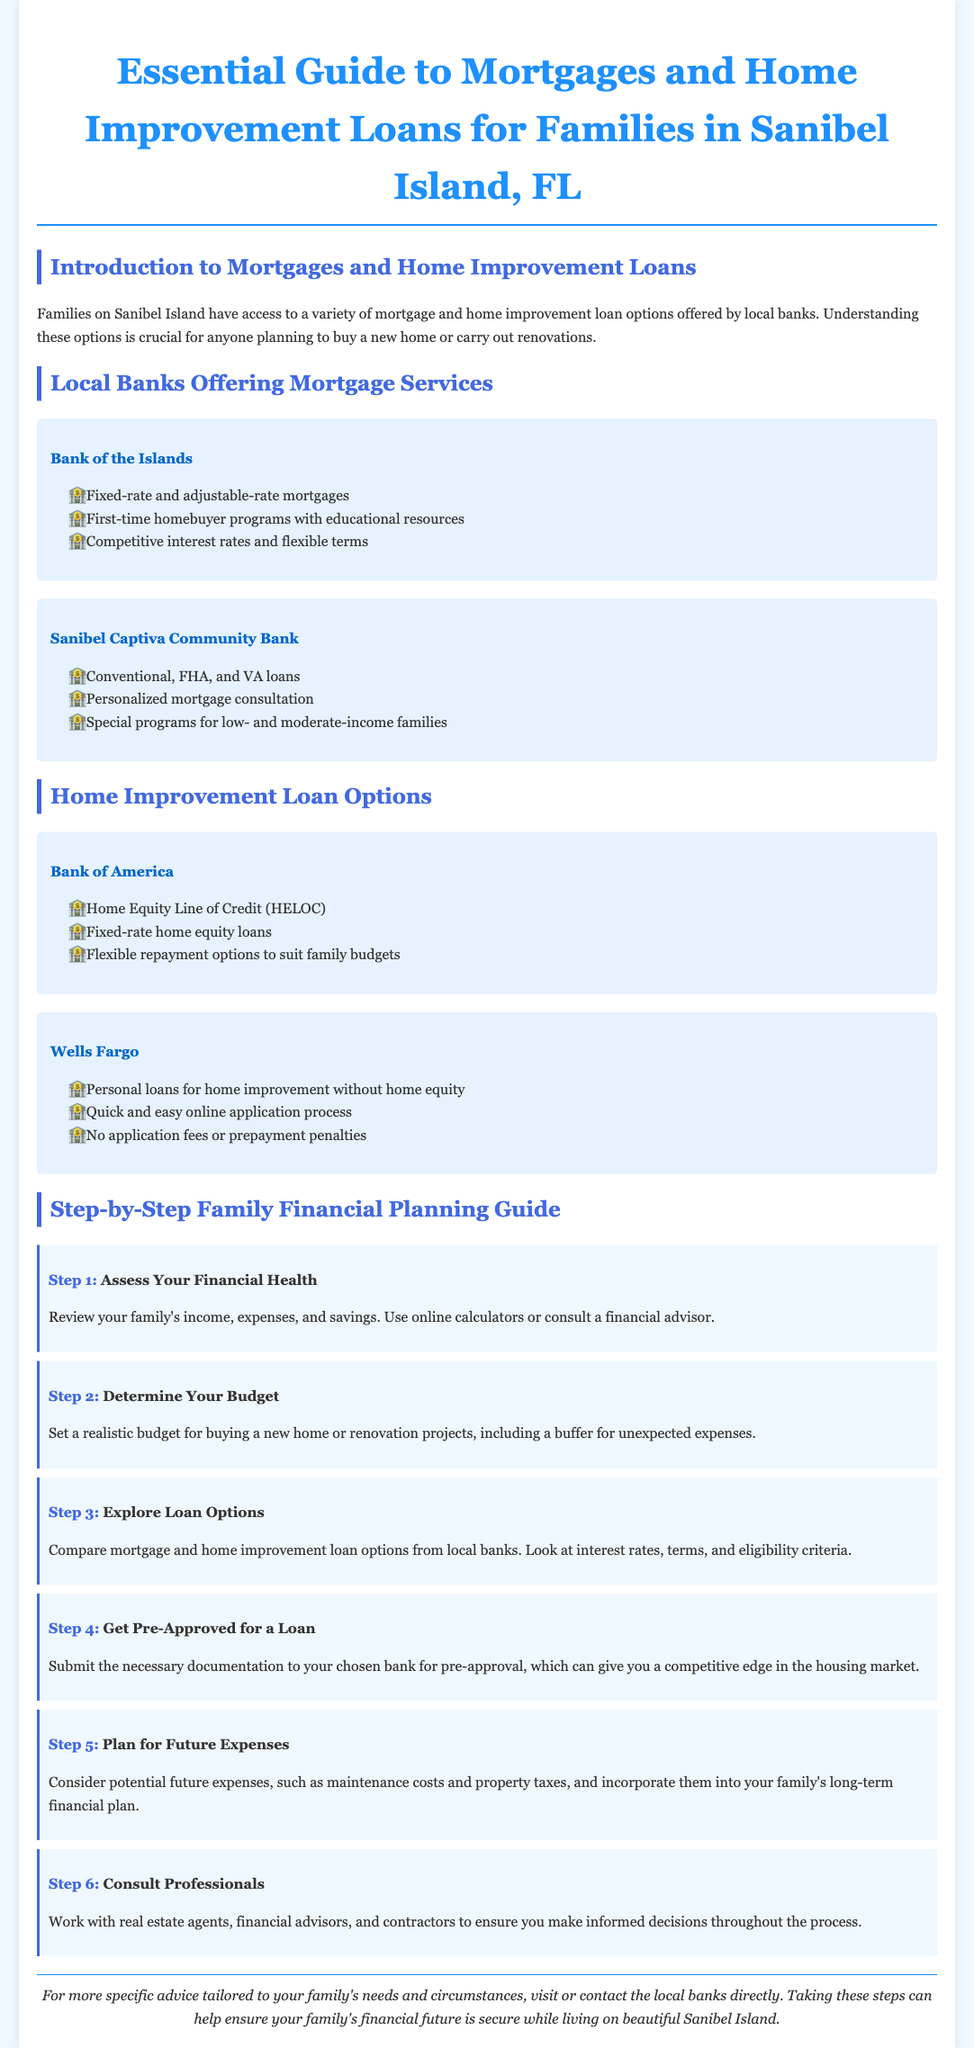What types of mortgage services does Bank of the Islands offer? The document lists fixed-rate and adjustable-rate mortgages, first-time homebuyer programs, competitive interest rates, and flexible terms available from Bank of the Islands.
Answer: Fixed-rate and adjustable-rate mortgages What loan options does Bank of America provide for home improvement? According to the document, Bank of America offers a Home Equity Line of Credit (HELOC) and fixed-rate home equity loans.
Answer: Home Equity Line of Credit (HELOC) How many steps are there in the family financial planning guide? The document outlines the family financial planning guide in six distinct steps.
Answer: 6 Which bank offers personalized mortgage consultation? The document states that Sanibel Captiva Community Bank provides personalized mortgage consultation as one of its services.
Answer: Sanibel Captiva Community Bank What is the first step in the financial planning guide? The first step is to assess your financial health, which involves reviewing income, expenses, and savings.
Answer: Assess Your Financial Health What program does Sanibel Captiva Community Bank have for low-income families? The document mentions that there are special programs for low- and moderate-income families available at Sanibel Captiva Community Bank.
Answer: Special programs What should families consider when planning for future expenses? The document advises families to consider maintenance costs and property taxes as part of their long-term financial plan.
Answer: Maintenance costs and property taxes What is the purpose of getting pre-approved for a loan? The document explains that getting pre-approved can give families a competitive edge in the housing market.
Answer: Competitive edge What is a suggested tool to assess financial health? The document suggests using online calculators or consulting a financial advisor as tools to assess financial health.
Answer: Online calculators or financial advisor 